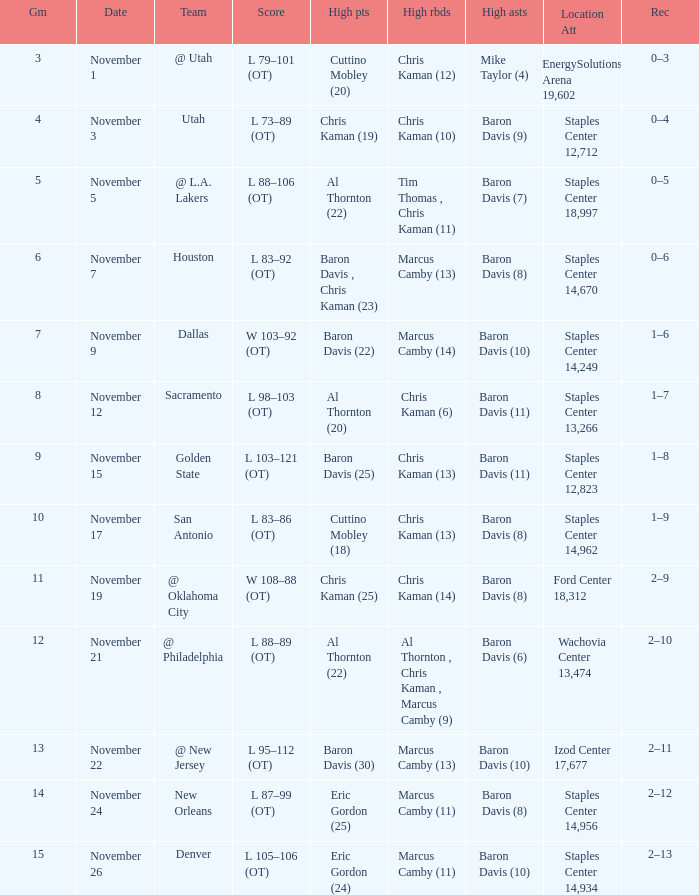Name the high assists for  l 98–103 (ot) Baron Davis (11). Parse the full table. {'header': ['Gm', 'Date', 'Team', 'Score', 'High pts', 'High rbds', 'High asts', 'Location Att', 'Rec'], 'rows': [['3', 'November 1', '@ Utah', 'L 79–101 (OT)', 'Cuttino Mobley (20)', 'Chris Kaman (12)', 'Mike Taylor (4)', 'EnergySolutions Arena 19,602', '0–3'], ['4', 'November 3', 'Utah', 'L 73–89 (OT)', 'Chris Kaman (19)', 'Chris Kaman (10)', 'Baron Davis (9)', 'Staples Center 12,712', '0–4'], ['5', 'November 5', '@ L.A. Lakers', 'L 88–106 (OT)', 'Al Thornton (22)', 'Tim Thomas , Chris Kaman (11)', 'Baron Davis (7)', 'Staples Center 18,997', '0–5'], ['6', 'November 7', 'Houston', 'L 83–92 (OT)', 'Baron Davis , Chris Kaman (23)', 'Marcus Camby (13)', 'Baron Davis (8)', 'Staples Center 14,670', '0–6'], ['7', 'November 9', 'Dallas', 'W 103–92 (OT)', 'Baron Davis (22)', 'Marcus Camby (14)', 'Baron Davis (10)', 'Staples Center 14,249', '1–6'], ['8', 'November 12', 'Sacramento', 'L 98–103 (OT)', 'Al Thornton (20)', 'Chris Kaman (6)', 'Baron Davis (11)', 'Staples Center 13,266', '1–7'], ['9', 'November 15', 'Golden State', 'L 103–121 (OT)', 'Baron Davis (25)', 'Chris Kaman (13)', 'Baron Davis (11)', 'Staples Center 12,823', '1–8'], ['10', 'November 17', 'San Antonio', 'L 83–86 (OT)', 'Cuttino Mobley (18)', 'Chris Kaman (13)', 'Baron Davis (8)', 'Staples Center 14,962', '1–9'], ['11', 'November 19', '@ Oklahoma City', 'W 108–88 (OT)', 'Chris Kaman (25)', 'Chris Kaman (14)', 'Baron Davis (8)', 'Ford Center 18,312', '2–9'], ['12', 'November 21', '@ Philadelphia', 'L 88–89 (OT)', 'Al Thornton (22)', 'Al Thornton , Chris Kaman , Marcus Camby (9)', 'Baron Davis (6)', 'Wachovia Center 13,474', '2–10'], ['13', 'November 22', '@ New Jersey', 'L 95–112 (OT)', 'Baron Davis (30)', 'Marcus Camby (13)', 'Baron Davis (10)', 'Izod Center 17,677', '2–11'], ['14', 'November 24', 'New Orleans', 'L 87–99 (OT)', 'Eric Gordon (25)', 'Marcus Camby (11)', 'Baron Davis (8)', 'Staples Center 14,956', '2–12'], ['15', 'November 26', 'Denver', 'L 105–106 (OT)', 'Eric Gordon (24)', 'Marcus Camby (11)', 'Baron Davis (10)', 'Staples Center 14,934', '2–13']]} 